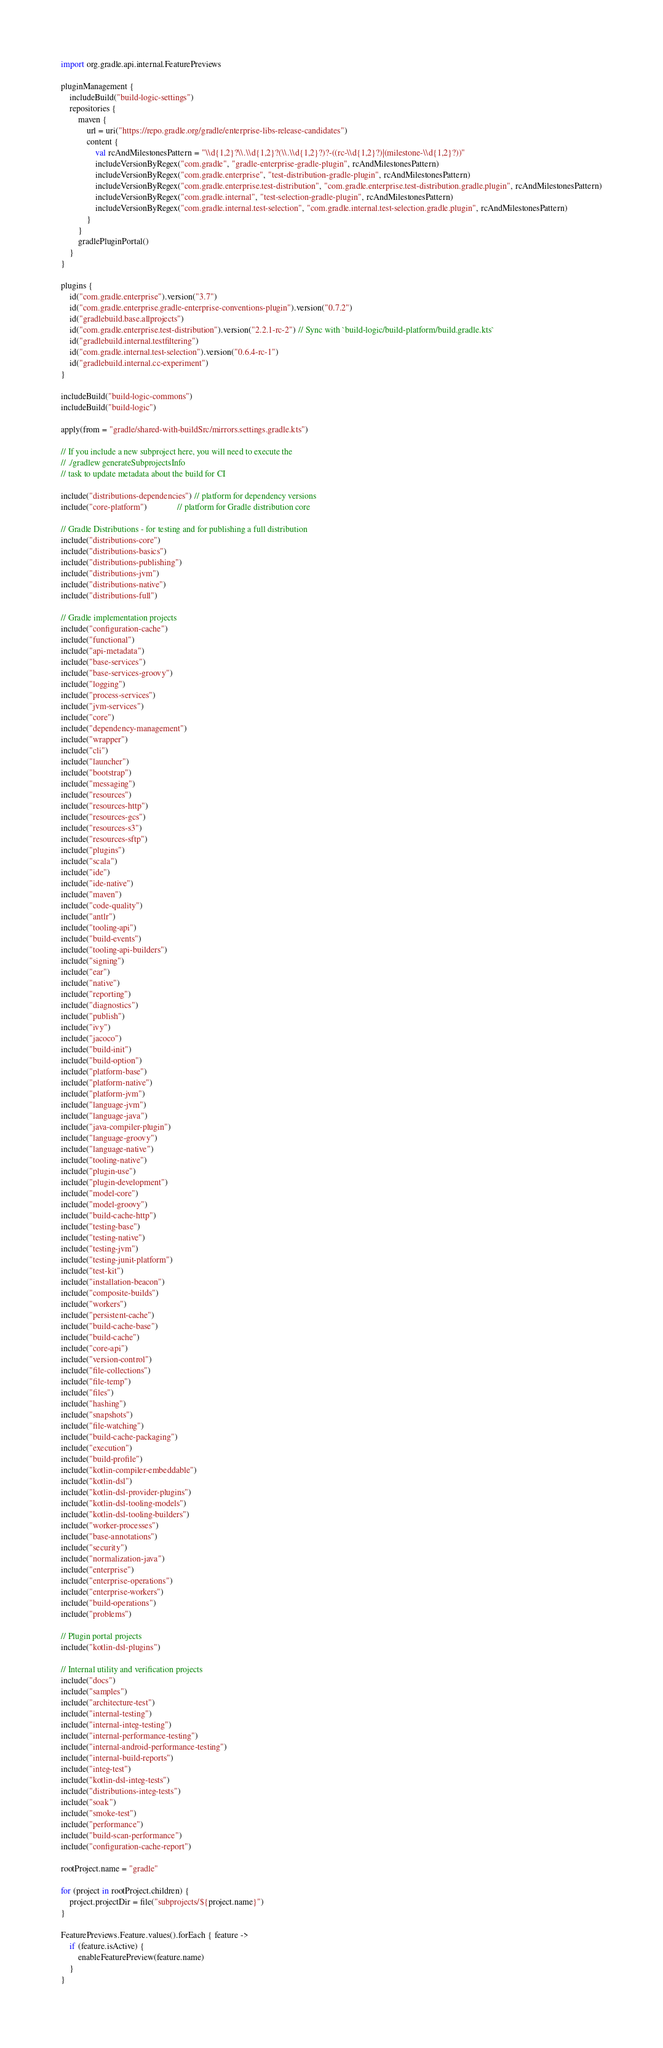<code> <loc_0><loc_0><loc_500><loc_500><_Kotlin_>import org.gradle.api.internal.FeaturePreviews

pluginManagement {
    includeBuild("build-logic-settings")
    repositories {
        maven {
            url = uri("https://repo.gradle.org/gradle/enterprise-libs-release-candidates")
            content {
                val rcAndMilestonesPattern = "\\d{1,2}?\\.\\d{1,2}?(\\.\\d{1,2}?)?-((rc-\\d{1,2}?)|(milestone-\\d{1,2}?))"
                includeVersionByRegex("com.gradle", "gradle-enterprise-gradle-plugin", rcAndMilestonesPattern)
                includeVersionByRegex("com.gradle.enterprise", "test-distribution-gradle-plugin", rcAndMilestonesPattern)
                includeVersionByRegex("com.gradle.enterprise.test-distribution", "com.gradle.enterprise.test-distribution.gradle.plugin", rcAndMilestonesPattern)
                includeVersionByRegex("com.gradle.internal", "test-selection-gradle-plugin", rcAndMilestonesPattern)
                includeVersionByRegex("com.gradle.internal.test-selection", "com.gradle.internal.test-selection.gradle.plugin", rcAndMilestonesPattern)
            }
        }
        gradlePluginPortal()
    }
}

plugins {
    id("com.gradle.enterprise").version("3.7")
    id("com.gradle.enterprise.gradle-enterprise-conventions-plugin").version("0.7.2")
    id("gradlebuild.base.allprojects")
    id("com.gradle.enterprise.test-distribution").version("2.2.1-rc-2") // Sync with `build-logic/build-platform/build.gradle.kts`
    id("gradlebuild.internal.testfiltering")
    id("com.gradle.internal.test-selection").version("0.6.4-rc-1")
    id("gradlebuild.internal.cc-experiment")
}

includeBuild("build-logic-commons")
includeBuild("build-logic")

apply(from = "gradle/shared-with-buildSrc/mirrors.settings.gradle.kts")

// If you include a new subproject here, you will need to execute the
// ./gradlew generateSubprojectsInfo
// task to update metadata about the build for CI

include("distributions-dependencies") // platform for dependency versions
include("core-platform")              // platform for Gradle distribution core

// Gradle Distributions - for testing and for publishing a full distribution
include("distributions-core")
include("distributions-basics")
include("distributions-publishing")
include("distributions-jvm")
include("distributions-native")
include("distributions-full")

// Gradle implementation projects
include("configuration-cache")
include("functional")
include("api-metadata")
include("base-services")
include("base-services-groovy")
include("logging")
include("process-services")
include("jvm-services")
include("core")
include("dependency-management")
include("wrapper")
include("cli")
include("launcher")
include("bootstrap")
include("messaging")
include("resources")
include("resources-http")
include("resources-gcs")
include("resources-s3")
include("resources-sftp")
include("plugins")
include("scala")
include("ide")
include("ide-native")
include("maven")
include("code-quality")
include("antlr")
include("tooling-api")
include("build-events")
include("tooling-api-builders")
include("signing")
include("ear")
include("native")
include("reporting")
include("diagnostics")
include("publish")
include("ivy")
include("jacoco")
include("build-init")
include("build-option")
include("platform-base")
include("platform-native")
include("platform-jvm")
include("language-jvm")
include("language-java")
include("java-compiler-plugin")
include("language-groovy")
include("language-native")
include("tooling-native")
include("plugin-use")
include("plugin-development")
include("model-core")
include("model-groovy")
include("build-cache-http")
include("testing-base")
include("testing-native")
include("testing-jvm")
include("testing-junit-platform")
include("test-kit")
include("installation-beacon")
include("composite-builds")
include("workers")
include("persistent-cache")
include("build-cache-base")
include("build-cache")
include("core-api")
include("version-control")
include("file-collections")
include("file-temp")
include("files")
include("hashing")
include("snapshots")
include("file-watching")
include("build-cache-packaging")
include("execution")
include("build-profile")
include("kotlin-compiler-embeddable")
include("kotlin-dsl")
include("kotlin-dsl-provider-plugins")
include("kotlin-dsl-tooling-models")
include("kotlin-dsl-tooling-builders")
include("worker-processes")
include("base-annotations")
include("security")
include("normalization-java")
include("enterprise")
include("enterprise-operations")
include("enterprise-workers")
include("build-operations")
include("problems")

// Plugin portal projects
include("kotlin-dsl-plugins")

// Internal utility and verification projects
include("docs")
include("samples")
include("architecture-test")
include("internal-testing")
include("internal-integ-testing")
include("internal-performance-testing")
include("internal-android-performance-testing")
include("internal-build-reports")
include("integ-test")
include("kotlin-dsl-integ-tests")
include("distributions-integ-tests")
include("soak")
include("smoke-test")
include("performance")
include("build-scan-performance")
include("configuration-cache-report")

rootProject.name = "gradle"

for (project in rootProject.children) {
    project.projectDir = file("subprojects/${project.name}")
}

FeaturePreviews.Feature.values().forEach { feature ->
    if (feature.isActive) {
        enableFeaturePreview(feature.name)
    }
}
</code> 